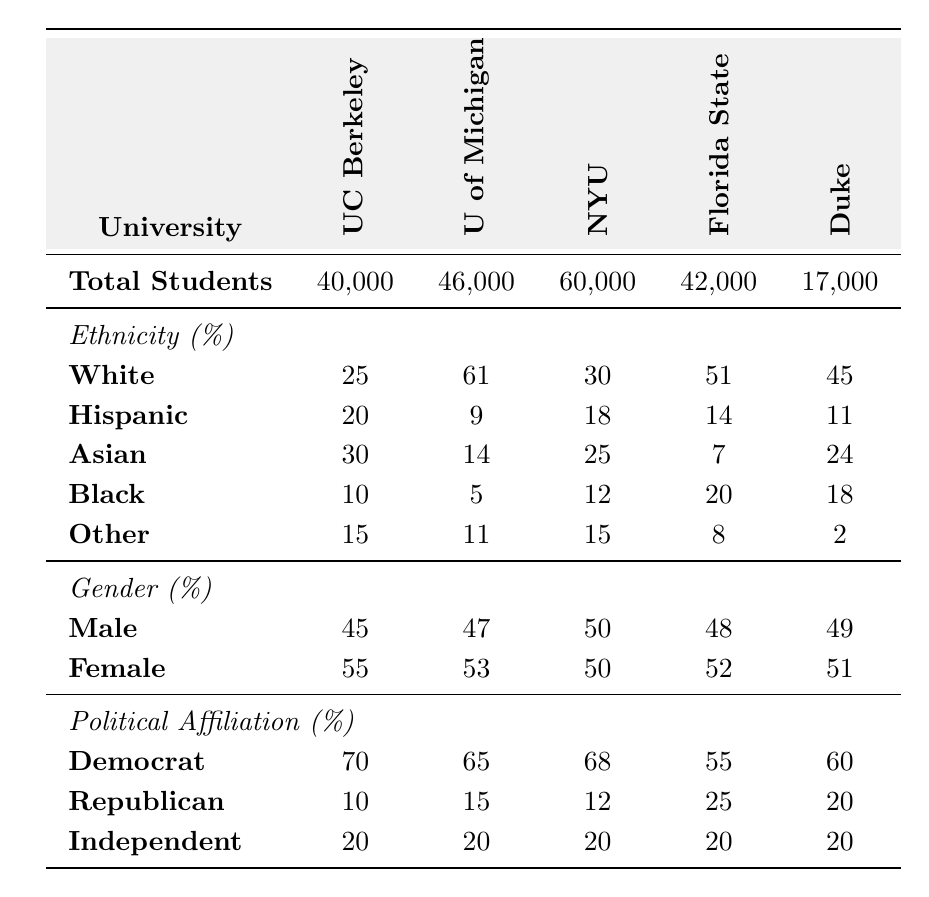What is the total number of students at New York University? The table states that New York University has a total of 60,000 students.
Answer: 60,000 Which university has the highest percentage of Hispanic students? By comparing the percentages of Hispanic students across the campuses, the University of California, Berkeley has the highest at 20%.
Answer: University of California, Berkeley What percentage of students at Florida State University identify as Independent? The table clearly shows that 20% of students at Florida State University identify as Independent.
Answer: 20% What is the average percentage of Democrat affiliation among the universities listed? To calculate the average percentage of Democrat affiliation: (70 + 65 + 68 + 55 + 60) / 5 = 63.6, so the average is approximately 64%.
Answer: 64% Does Duke University have a lower percentage of Republican students than New York University? Duke University has 20% Republican students, while New York University has 12%, thus, yes, it has a lower percentage.
Answer: Yes Which ethnicity group has the lowest representation at the University of Michigan? The data shows that the Black ethnicity group has the lowest representation at 5%.
Answer: Black If you combine the percentages of Asian and Other ethnicities at University of California, Berkeley, what would the total be? The percentages of Asian (30%) and Other (15%) at UC Berkeley add up to 30 + 15 = 45%.
Answer: 45% How many universities have a majority of female students? The data shows that all the universities listed have more female students compared to male students (i.e., University of California, Berkeley, University of Michigan, NYU, Florida State University, and Duke University).
Answer: 5 Is the total percentage of Republican students at Florida State University greater than the total percentage of Democrat students? The table indicates that Florida State University has 25% Republican and 55% Democrat students, so the statement is false.
Answer: No Calculate the difference in percentage of Independent students between University of Michigan and Duke University. The Independent percentages are identical at 20% for both universities, so the difference is 20 - 20 = 0%.
Answer: 0% 